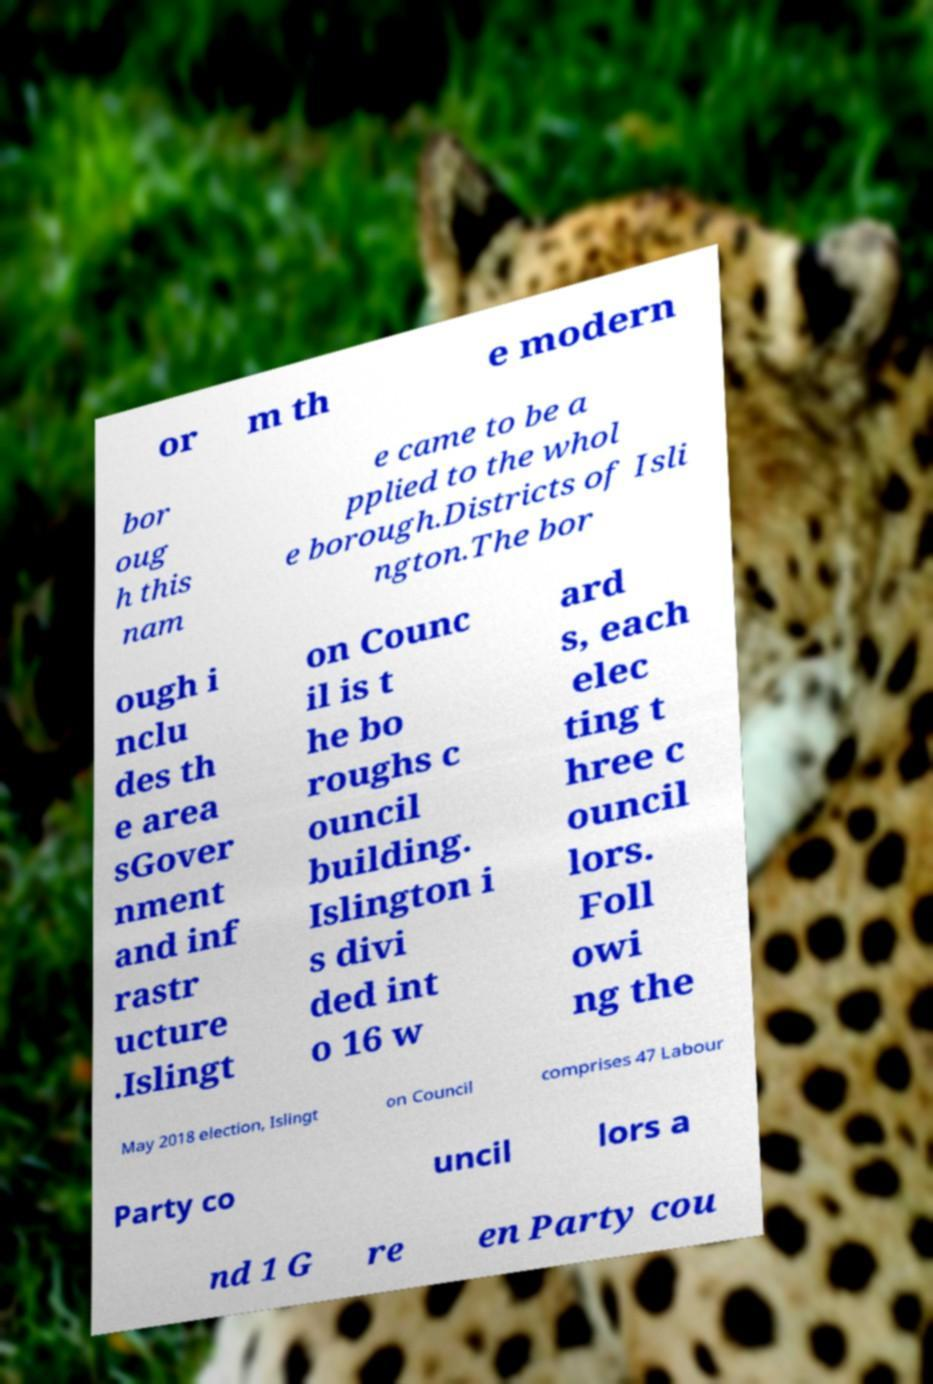Could you assist in decoding the text presented in this image and type it out clearly? or m th e modern bor oug h this nam e came to be a pplied to the whol e borough.Districts of Isli ngton.The bor ough i nclu des th e area sGover nment and inf rastr ucture .Islingt on Counc il is t he bo roughs c ouncil building. Islington i s divi ded int o 16 w ard s, each elec ting t hree c ouncil lors. Foll owi ng the May 2018 election, Islingt on Council comprises 47 Labour Party co uncil lors a nd 1 G re en Party cou 